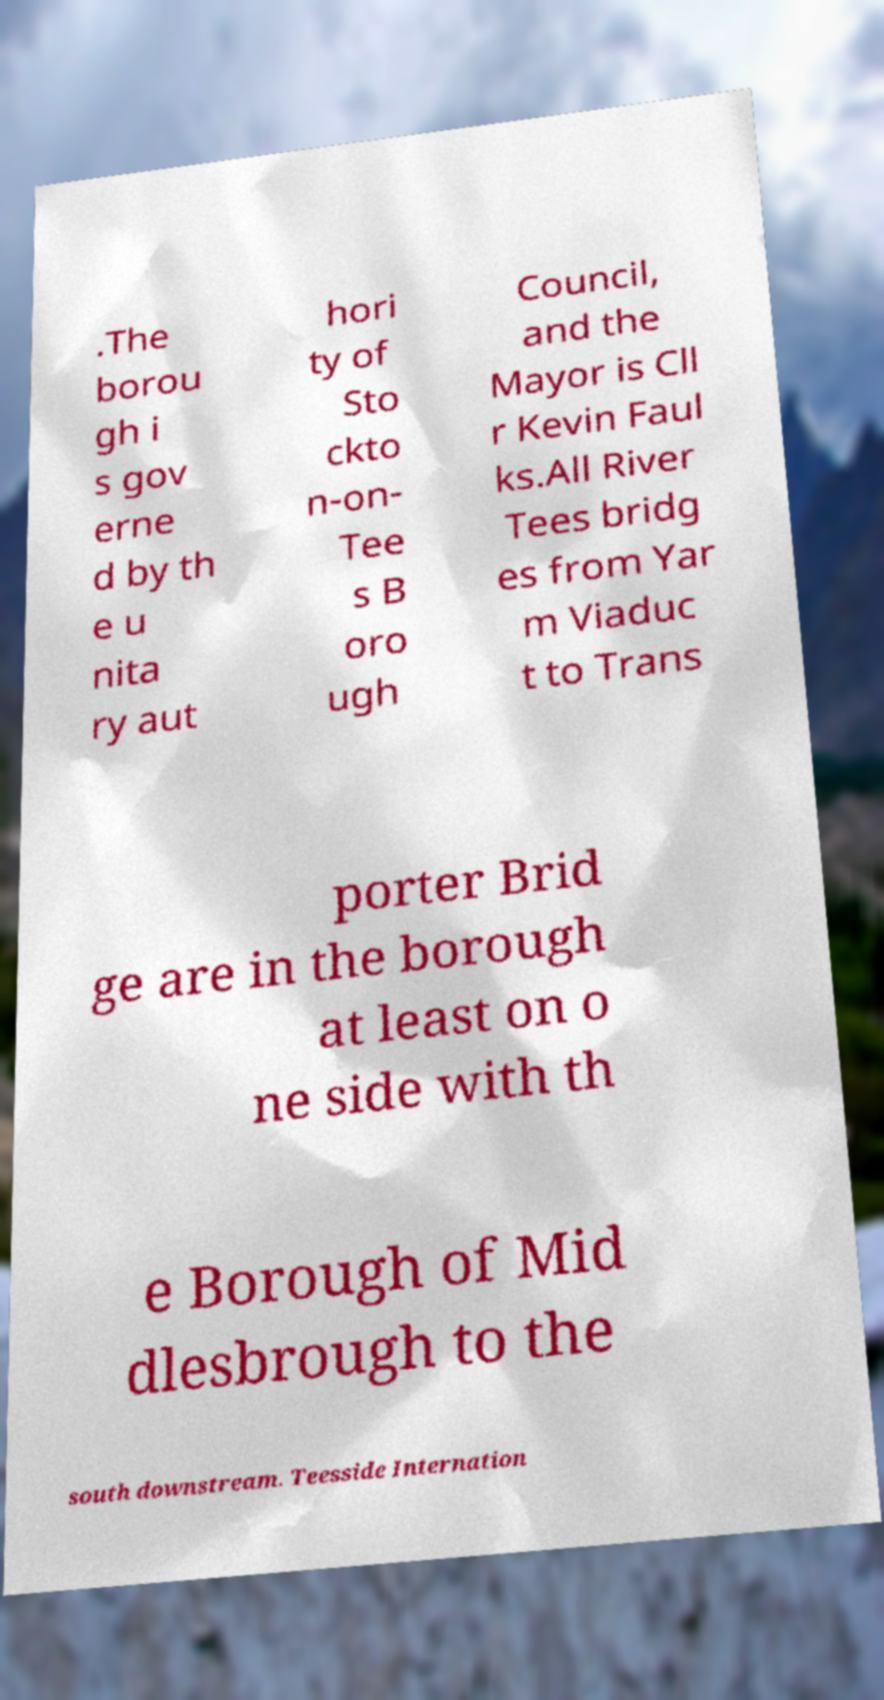Please read and relay the text visible in this image. What does it say? .The borou gh i s gov erne d by th e u nita ry aut hori ty of Sto ckto n-on- Tee s B oro ugh Council, and the Mayor is Cll r Kevin Faul ks.All River Tees bridg es from Yar m Viaduc t to Trans porter Brid ge are in the borough at least on o ne side with th e Borough of Mid dlesbrough to the south downstream. Teesside Internation 